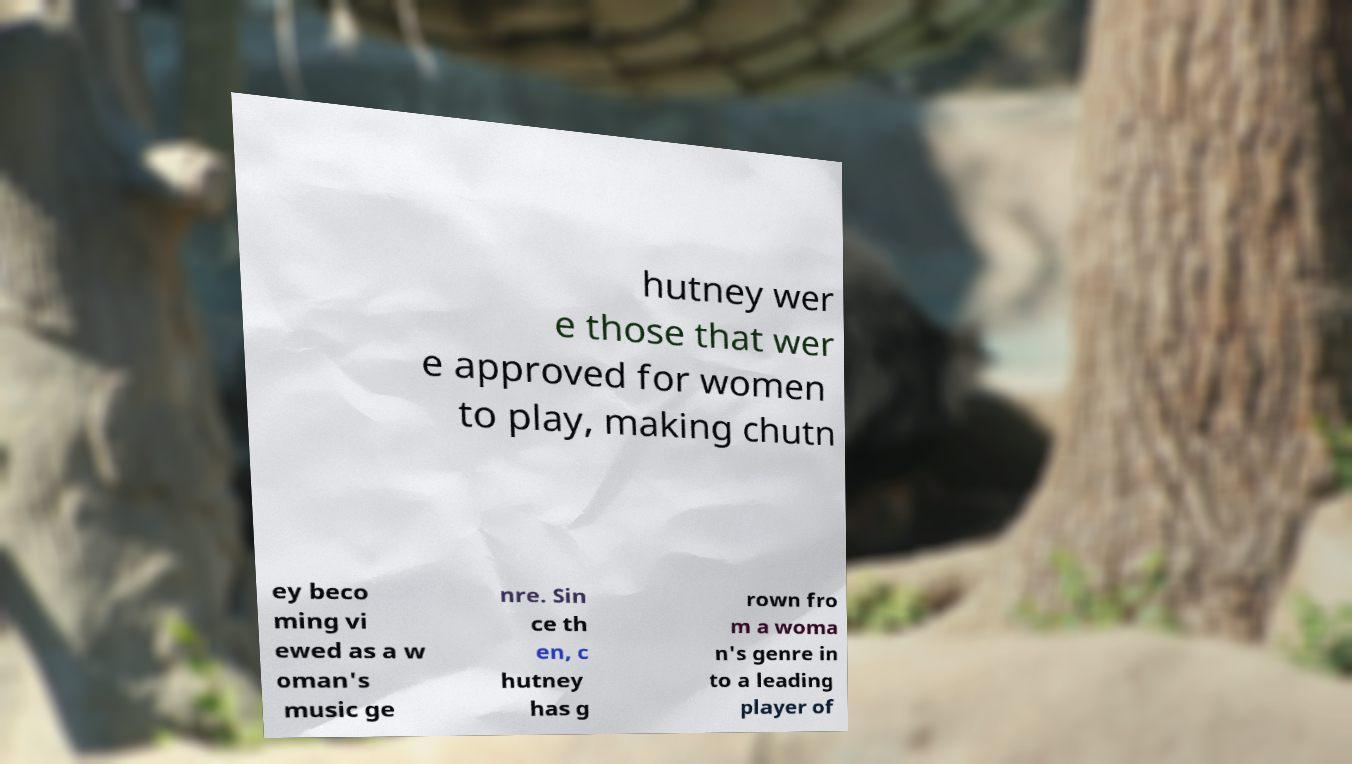Can you read and provide the text displayed in the image?This photo seems to have some interesting text. Can you extract and type it out for me? hutney wer e those that wer e approved for women to play, making chutn ey beco ming vi ewed as a w oman's music ge nre. Sin ce th en, c hutney has g rown fro m a woma n's genre in to a leading player of 